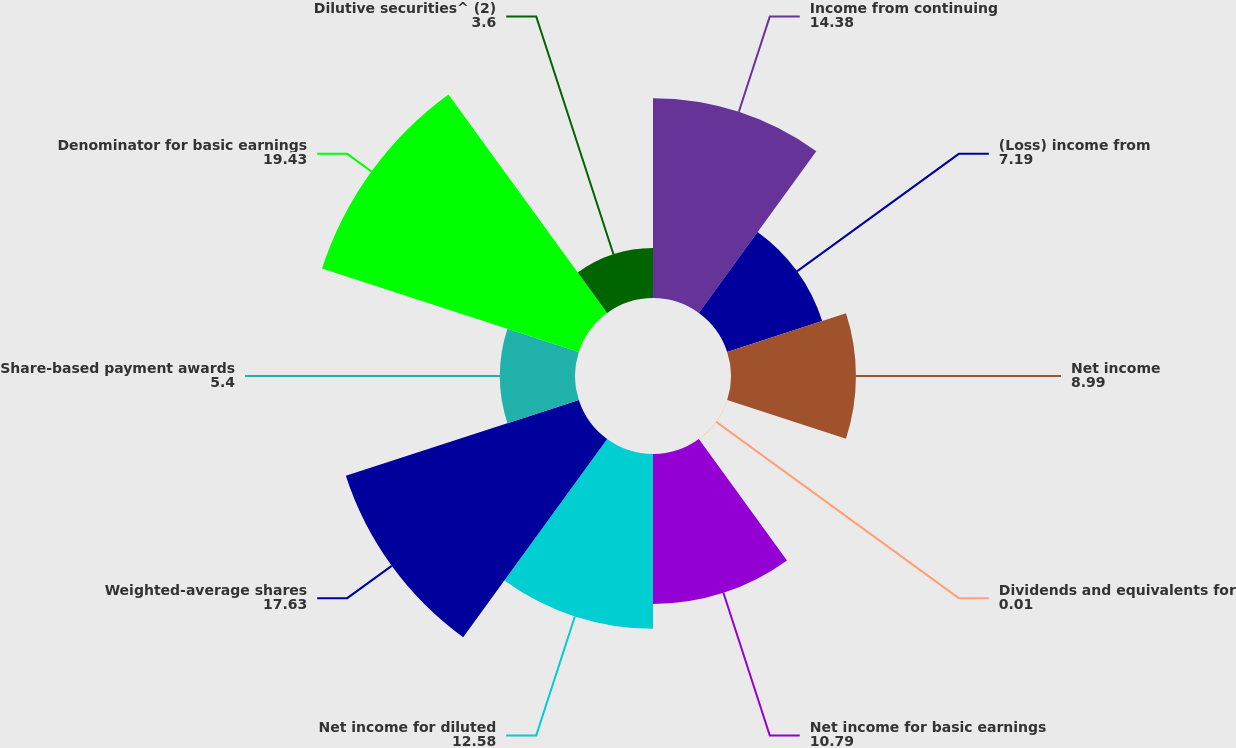<chart> <loc_0><loc_0><loc_500><loc_500><pie_chart><fcel>Income from continuing<fcel>(Loss) income from<fcel>Net income<fcel>Dividends and equivalents for<fcel>Net income for basic earnings<fcel>Net income for diluted<fcel>Weighted-average shares<fcel>Share-based payment awards<fcel>Denominator for basic earnings<fcel>Dilutive securities^ (2)<nl><fcel>14.38%<fcel>7.19%<fcel>8.99%<fcel>0.01%<fcel>10.79%<fcel>12.58%<fcel>17.63%<fcel>5.4%<fcel>19.43%<fcel>3.6%<nl></chart> 